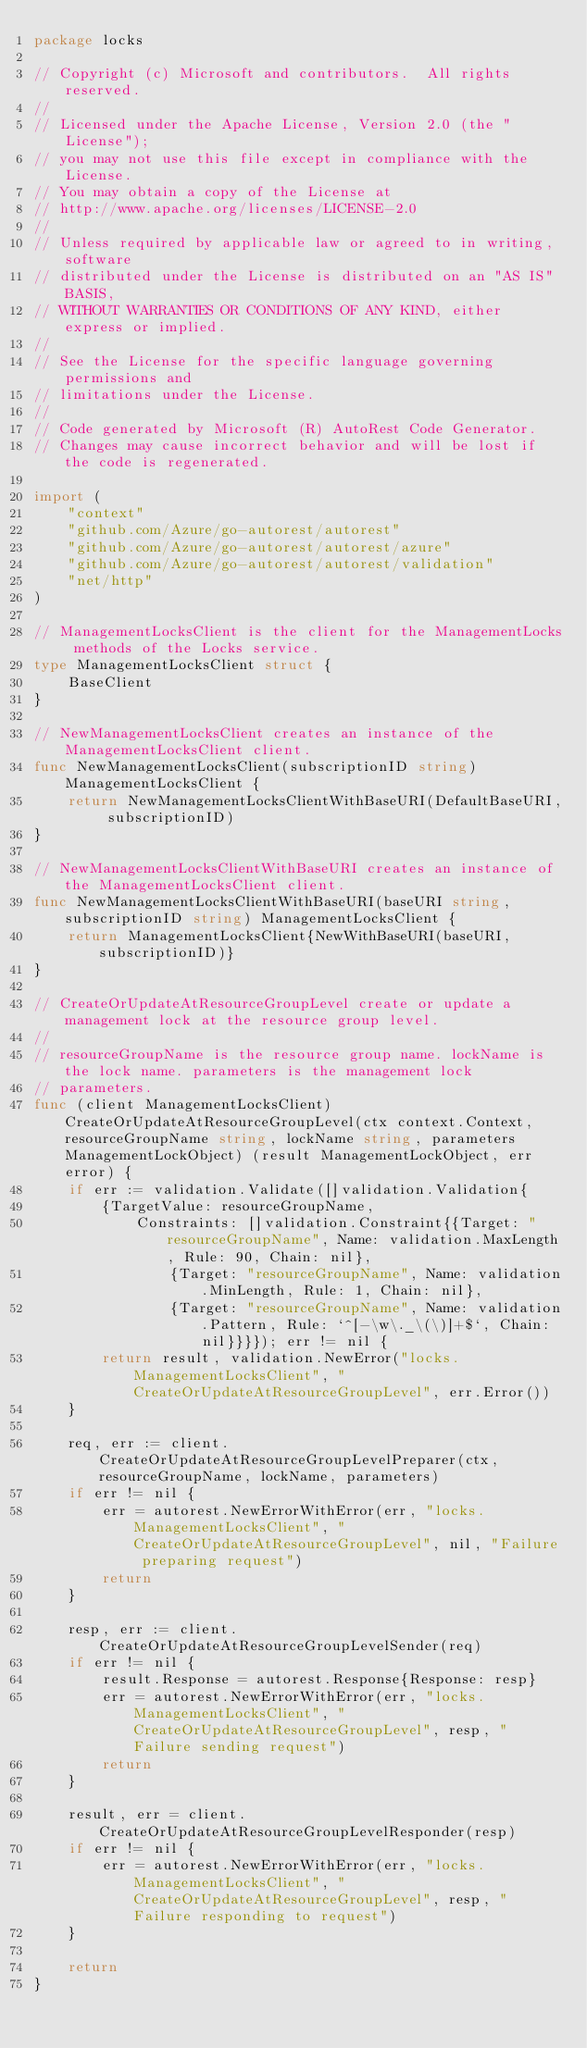<code> <loc_0><loc_0><loc_500><loc_500><_Go_>package locks

// Copyright (c) Microsoft and contributors.  All rights reserved.
//
// Licensed under the Apache License, Version 2.0 (the "License");
// you may not use this file except in compliance with the License.
// You may obtain a copy of the License at
// http://www.apache.org/licenses/LICENSE-2.0
//
// Unless required by applicable law or agreed to in writing, software
// distributed under the License is distributed on an "AS IS" BASIS,
// WITHOUT WARRANTIES OR CONDITIONS OF ANY KIND, either express or implied.
//
// See the License for the specific language governing permissions and
// limitations under the License.
//
// Code generated by Microsoft (R) AutoRest Code Generator.
// Changes may cause incorrect behavior and will be lost if the code is regenerated.

import (
	"context"
	"github.com/Azure/go-autorest/autorest"
	"github.com/Azure/go-autorest/autorest/azure"
	"github.com/Azure/go-autorest/autorest/validation"
	"net/http"
)

// ManagementLocksClient is the client for the ManagementLocks methods of the Locks service.
type ManagementLocksClient struct {
	BaseClient
}

// NewManagementLocksClient creates an instance of the ManagementLocksClient client.
func NewManagementLocksClient(subscriptionID string) ManagementLocksClient {
	return NewManagementLocksClientWithBaseURI(DefaultBaseURI, subscriptionID)
}

// NewManagementLocksClientWithBaseURI creates an instance of the ManagementLocksClient client.
func NewManagementLocksClientWithBaseURI(baseURI string, subscriptionID string) ManagementLocksClient {
	return ManagementLocksClient{NewWithBaseURI(baseURI, subscriptionID)}
}

// CreateOrUpdateAtResourceGroupLevel create or update a management lock at the resource group level.
//
// resourceGroupName is the resource group name. lockName is the lock name. parameters is the management lock
// parameters.
func (client ManagementLocksClient) CreateOrUpdateAtResourceGroupLevel(ctx context.Context, resourceGroupName string, lockName string, parameters ManagementLockObject) (result ManagementLockObject, err error) {
	if err := validation.Validate([]validation.Validation{
		{TargetValue: resourceGroupName,
			Constraints: []validation.Constraint{{Target: "resourceGroupName", Name: validation.MaxLength, Rule: 90, Chain: nil},
				{Target: "resourceGroupName", Name: validation.MinLength, Rule: 1, Chain: nil},
				{Target: "resourceGroupName", Name: validation.Pattern, Rule: `^[-\w\._\(\)]+$`, Chain: nil}}}}); err != nil {
		return result, validation.NewError("locks.ManagementLocksClient", "CreateOrUpdateAtResourceGroupLevel", err.Error())
	}

	req, err := client.CreateOrUpdateAtResourceGroupLevelPreparer(ctx, resourceGroupName, lockName, parameters)
	if err != nil {
		err = autorest.NewErrorWithError(err, "locks.ManagementLocksClient", "CreateOrUpdateAtResourceGroupLevel", nil, "Failure preparing request")
		return
	}

	resp, err := client.CreateOrUpdateAtResourceGroupLevelSender(req)
	if err != nil {
		result.Response = autorest.Response{Response: resp}
		err = autorest.NewErrorWithError(err, "locks.ManagementLocksClient", "CreateOrUpdateAtResourceGroupLevel", resp, "Failure sending request")
		return
	}

	result, err = client.CreateOrUpdateAtResourceGroupLevelResponder(resp)
	if err != nil {
		err = autorest.NewErrorWithError(err, "locks.ManagementLocksClient", "CreateOrUpdateAtResourceGroupLevel", resp, "Failure responding to request")
	}

	return
}
</code> 